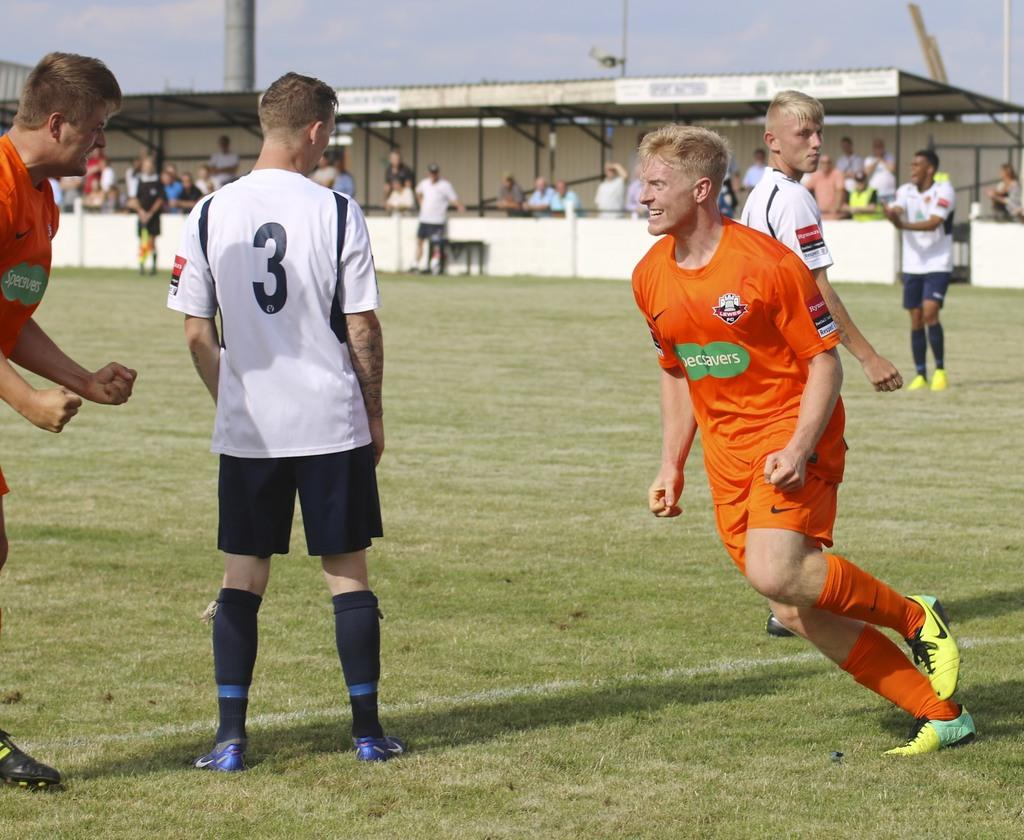<image>
Present a compact description of the photo's key features. Men play sports, one of them with a number three on his back. 